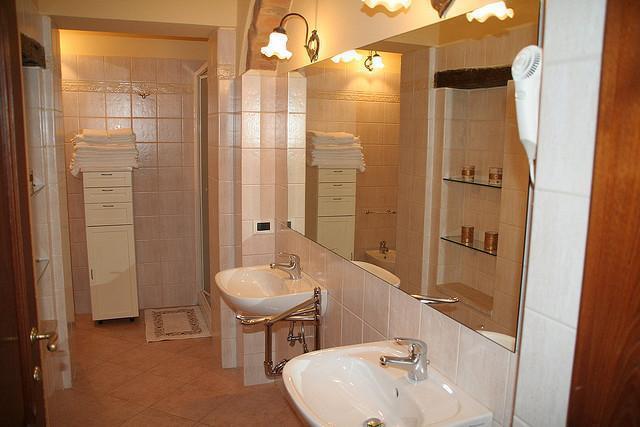What typical bathroom item is integrated into the wall that normally is free standing?
Pick the right solution, then justify: 'Answer: answer
Rationale: rationale.'
Options: Plumbing, hair dryer, mirror, sink. Answer: hair dryer.
Rationale: The bathroom has a hair dryer. 